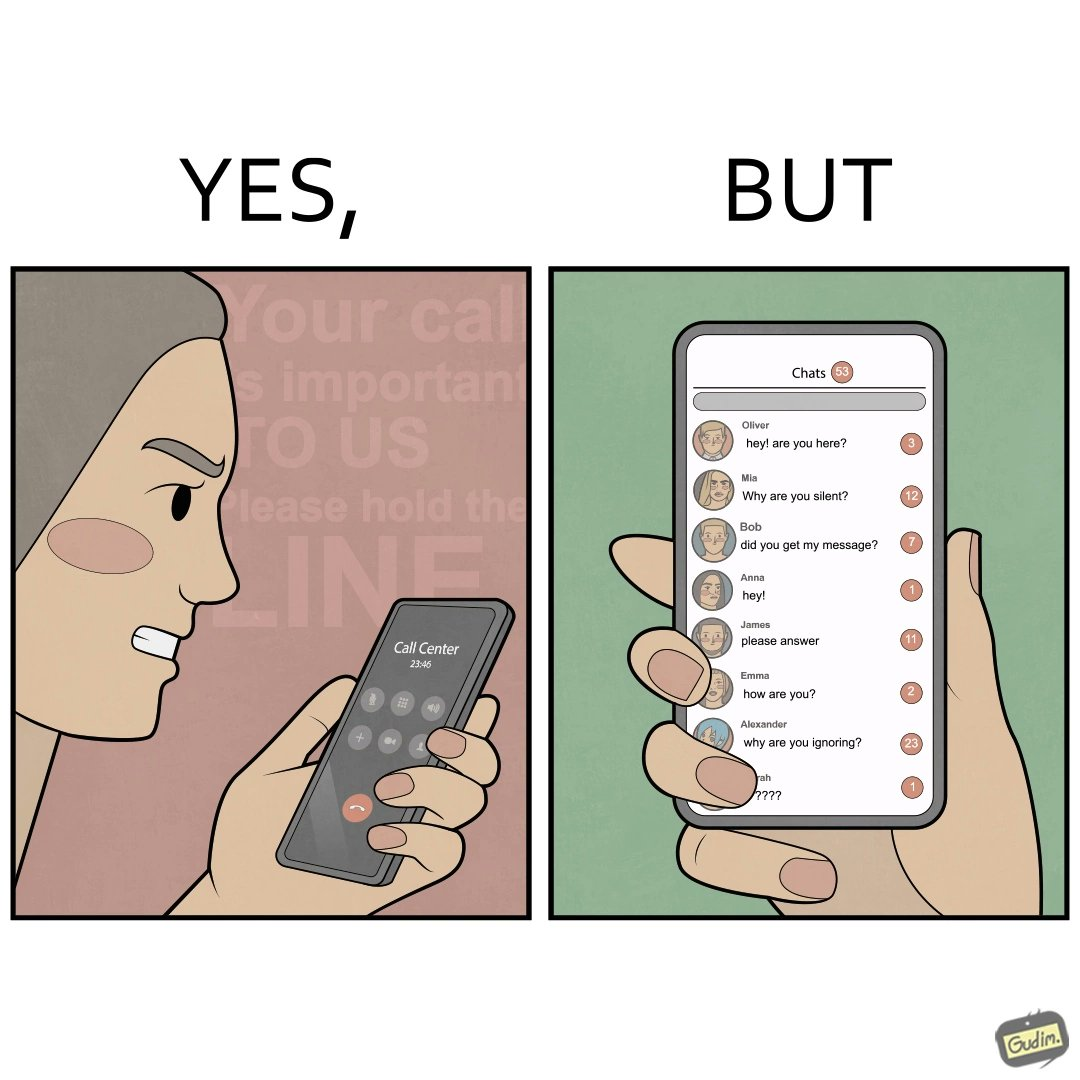What is shown in this image? The image is ironical because while the woman is annoyed by the unresponsiveness of the call center, she herself is being unresponsive to many people in the chat. 